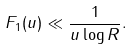<formula> <loc_0><loc_0><loc_500><loc_500>F _ { 1 } ( u ) \ll \frac { 1 } { u \log R } .</formula> 